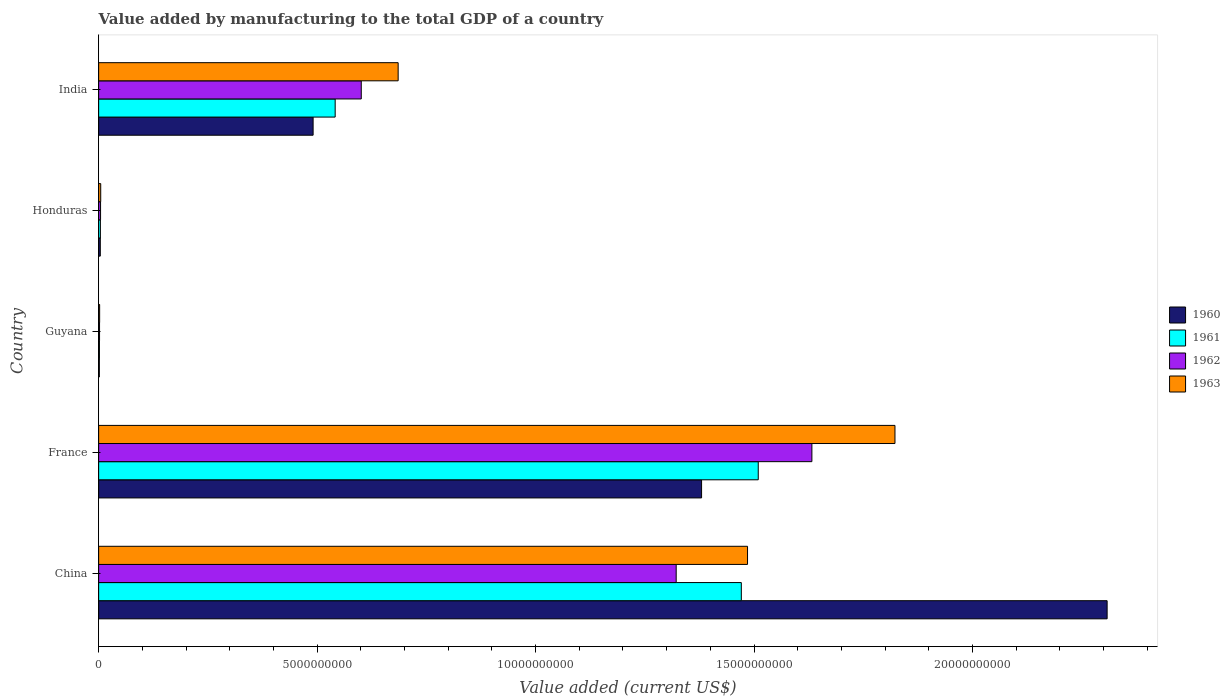How many groups of bars are there?
Your answer should be compact. 5. Are the number of bars per tick equal to the number of legend labels?
Your response must be concise. Yes. How many bars are there on the 4th tick from the top?
Your response must be concise. 4. What is the label of the 3rd group of bars from the top?
Provide a short and direct response. Guyana. What is the value added by manufacturing to the total GDP in 1963 in China?
Keep it short and to the point. 1.49e+1. Across all countries, what is the maximum value added by manufacturing to the total GDP in 1963?
Offer a very short reply. 1.82e+1. Across all countries, what is the minimum value added by manufacturing to the total GDP in 1961?
Provide a succinct answer. 1.84e+07. In which country was the value added by manufacturing to the total GDP in 1960 maximum?
Provide a succinct answer. China. In which country was the value added by manufacturing to the total GDP in 1963 minimum?
Your answer should be very brief. Guyana. What is the total value added by manufacturing to the total GDP in 1963 in the graph?
Your response must be concise. 4.00e+1. What is the difference between the value added by manufacturing to the total GDP in 1960 in China and that in Guyana?
Offer a terse response. 2.31e+1. What is the difference between the value added by manufacturing to the total GDP in 1960 in Honduras and the value added by manufacturing to the total GDP in 1961 in China?
Keep it short and to the point. -1.47e+1. What is the average value added by manufacturing to the total GDP in 1961 per country?
Give a very brief answer. 7.06e+09. What is the difference between the value added by manufacturing to the total GDP in 1962 and value added by manufacturing to the total GDP in 1960 in China?
Offer a very short reply. -9.86e+09. In how many countries, is the value added by manufacturing to the total GDP in 1962 greater than 13000000000 US$?
Ensure brevity in your answer.  2. What is the ratio of the value added by manufacturing to the total GDP in 1963 in France to that in Guyana?
Your answer should be compact. 786.97. What is the difference between the highest and the second highest value added by manufacturing to the total GDP in 1962?
Provide a short and direct response. 3.11e+09. What is the difference between the highest and the lowest value added by manufacturing to the total GDP in 1963?
Keep it short and to the point. 1.82e+1. In how many countries, is the value added by manufacturing to the total GDP in 1962 greater than the average value added by manufacturing to the total GDP in 1962 taken over all countries?
Your answer should be compact. 2. How many bars are there?
Offer a very short reply. 20. Are all the bars in the graph horizontal?
Provide a succinct answer. Yes. How many countries are there in the graph?
Your answer should be very brief. 5. Are the values on the major ticks of X-axis written in scientific E-notation?
Provide a short and direct response. No. Does the graph contain any zero values?
Offer a terse response. No. Does the graph contain grids?
Ensure brevity in your answer.  No. Where does the legend appear in the graph?
Keep it short and to the point. Center right. How many legend labels are there?
Ensure brevity in your answer.  4. How are the legend labels stacked?
Offer a very short reply. Vertical. What is the title of the graph?
Your answer should be very brief. Value added by manufacturing to the total GDP of a country. What is the label or title of the X-axis?
Your answer should be compact. Value added (current US$). What is the Value added (current US$) in 1960 in China?
Provide a short and direct response. 2.31e+1. What is the Value added (current US$) in 1961 in China?
Offer a terse response. 1.47e+1. What is the Value added (current US$) of 1962 in China?
Ensure brevity in your answer.  1.32e+1. What is the Value added (current US$) in 1963 in China?
Keep it short and to the point. 1.49e+1. What is the Value added (current US$) of 1960 in France?
Your answer should be very brief. 1.38e+1. What is the Value added (current US$) of 1961 in France?
Your answer should be compact. 1.51e+1. What is the Value added (current US$) of 1962 in France?
Keep it short and to the point. 1.63e+1. What is the Value added (current US$) of 1963 in France?
Offer a very short reply. 1.82e+1. What is the Value added (current US$) of 1960 in Guyana?
Provide a short and direct response. 1.59e+07. What is the Value added (current US$) in 1961 in Guyana?
Give a very brief answer. 1.84e+07. What is the Value added (current US$) of 1962 in Guyana?
Ensure brevity in your answer.  2.08e+07. What is the Value added (current US$) of 1963 in Guyana?
Provide a short and direct response. 2.32e+07. What is the Value added (current US$) in 1960 in Honduras?
Keep it short and to the point. 3.80e+07. What is the Value added (current US$) in 1961 in Honduras?
Keep it short and to the point. 4.00e+07. What is the Value added (current US$) in 1962 in Honduras?
Provide a short and direct response. 4.41e+07. What is the Value added (current US$) in 1963 in Honduras?
Offer a very short reply. 4.76e+07. What is the Value added (current US$) in 1960 in India?
Offer a very short reply. 4.91e+09. What is the Value added (current US$) of 1961 in India?
Make the answer very short. 5.41e+09. What is the Value added (current US$) in 1962 in India?
Your answer should be very brief. 6.01e+09. What is the Value added (current US$) of 1963 in India?
Provide a short and direct response. 6.85e+09. Across all countries, what is the maximum Value added (current US$) in 1960?
Your answer should be very brief. 2.31e+1. Across all countries, what is the maximum Value added (current US$) of 1961?
Provide a short and direct response. 1.51e+1. Across all countries, what is the maximum Value added (current US$) of 1962?
Offer a very short reply. 1.63e+1. Across all countries, what is the maximum Value added (current US$) of 1963?
Offer a very short reply. 1.82e+1. Across all countries, what is the minimum Value added (current US$) in 1960?
Give a very brief answer. 1.59e+07. Across all countries, what is the minimum Value added (current US$) of 1961?
Ensure brevity in your answer.  1.84e+07. Across all countries, what is the minimum Value added (current US$) in 1962?
Ensure brevity in your answer.  2.08e+07. Across all countries, what is the minimum Value added (current US$) of 1963?
Offer a very short reply. 2.32e+07. What is the total Value added (current US$) of 1960 in the graph?
Provide a succinct answer. 4.18e+1. What is the total Value added (current US$) in 1961 in the graph?
Give a very brief answer. 3.53e+1. What is the total Value added (current US$) of 1962 in the graph?
Provide a succinct answer. 3.56e+1. What is the total Value added (current US$) of 1963 in the graph?
Your answer should be compact. 4.00e+1. What is the difference between the Value added (current US$) of 1960 in China and that in France?
Offer a very short reply. 9.28e+09. What is the difference between the Value added (current US$) of 1961 in China and that in France?
Make the answer very short. -3.87e+08. What is the difference between the Value added (current US$) of 1962 in China and that in France?
Keep it short and to the point. -3.11e+09. What is the difference between the Value added (current US$) of 1963 in China and that in France?
Your answer should be compact. -3.37e+09. What is the difference between the Value added (current US$) in 1960 in China and that in Guyana?
Offer a very short reply. 2.31e+1. What is the difference between the Value added (current US$) in 1961 in China and that in Guyana?
Keep it short and to the point. 1.47e+1. What is the difference between the Value added (current US$) of 1962 in China and that in Guyana?
Offer a very short reply. 1.32e+1. What is the difference between the Value added (current US$) of 1963 in China and that in Guyana?
Make the answer very short. 1.48e+1. What is the difference between the Value added (current US$) in 1960 in China and that in Honduras?
Give a very brief answer. 2.30e+1. What is the difference between the Value added (current US$) of 1961 in China and that in Honduras?
Keep it short and to the point. 1.47e+1. What is the difference between the Value added (current US$) in 1962 in China and that in Honduras?
Your answer should be compact. 1.32e+1. What is the difference between the Value added (current US$) of 1963 in China and that in Honduras?
Provide a succinct answer. 1.48e+1. What is the difference between the Value added (current US$) of 1960 in China and that in India?
Your answer should be very brief. 1.82e+1. What is the difference between the Value added (current US$) of 1961 in China and that in India?
Your answer should be compact. 9.30e+09. What is the difference between the Value added (current US$) in 1962 in China and that in India?
Give a very brief answer. 7.21e+09. What is the difference between the Value added (current US$) of 1963 in China and that in India?
Offer a very short reply. 8.00e+09. What is the difference between the Value added (current US$) of 1960 in France and that in Guyana?
Give a very brief answer. 1.38e+1. What is the difference between the Value added (current US$) in 1961 in France and that in Guyana?
Your answer should be very brief. 1.51e+1. What is the difference between the Value added (current US$) of 1962 in France and that in Guyana?
Give a very brief answer. 1.63e+1. What is the difference between the Value added (current US$) in 1963 in France and that in Guyana?
Offer a very short reply. 1.82e+1. What is the difference between the Value added (current US$) in 1960 in France and that in Honduras?
Keep it short and to the point. 1.38e+1. What is the difference between the Value added (current US$) in 1961 in France and that in Honduras?
Give a very brief answer. 1.51e+1. What is the difference between the Value added (current US$) in 1962 in France and that in Honduras?
Give a very brief answer. 1.63e+1. What is the difference between the Value added (current US$) of 1963 in France and that in Honduras?
Give a very brief answer. 1.82e+1. What is the difference between the Value added (current US$) in 1960 in France and that in India?
Your response must be concise. 8.89e+09. What is the difference between the Value added (current US$) in 1961 in France and that in India?
Keep it short and to the point. 9.68e+09. What is the difference between the Value added (current US$) in 1962 in France and that in India?
Your response must be concise. 1.03e+1. What is the difference between the Value added (current US$) of 1963 in France and that in India?
Offer a terse response. 1.14e+1. What is the difference between the Value added (current US$) in 1960 in Guyana and that in Honduras?
Make the answer very short. -2.22e+07. What is the difference between the Value added (current US$) in 1961 in Guyana and that in Honduras?
Your response must be concise. -2.17e+07. What is the difference between the Value added (current US$) in 1962 in Guyana and that in Honduras?
Offer a terse response. -2.33e+07. What is the difference between the Value added (current US$) in 1963 in Guyana and that in Honduras?
Keep it short and to the point. -2.44e+07. What is the difference between the Value added (current US$) in 1960 in Guyana and that in India?
Provide a succinct answer. -4.89e+09. What is the difference between the Value added (current US$) in 1961 in Guyana and that in India?
Give a very brief answer. -5.40e+09. What is the difference between the Value added (current US$) in 1962 in Guyana and that in India?
Your answer should be very brief. -5.99e+09. What is the difference between the Value added (current US$) in 1963 in Guyana and that in India?
Provide a short and direct response. -6.83e+09. What is the difference between the Value added (current US$) of 1960 in Honduras and that in India?
Make the answer very short. -4.87e+09. What is the difference between the Value added (current US$) in 1961 in Honduras and that in India?
Provide a succinct answer. -5.37e+09. What is the difference between the Value added (current US$) in 1962 in Honduras and that in India?
Keep it short and to the point. -5.97e+09. What is the difference between the Value added (current US$) of 1963 in Honduras and that in India?
Ensure brevity in your answer.  -6.81e+09. What is the difference between the Value added (current US$) of 1960 in China and the Value added (current US$) of 1961 in France?
Ensure brevity in your answer.  7.98e+09. What is the difference between the Value added (current US$) of 1960 in China and the Value added (current US$) of 1962 in France?
Your answer should be very brief. 6.76e+09. What is the difference between the Value added (current US$) in 1960 in China and the Value added (current US$) in 1963 in France?
Offer a very short reply. 4.86e+09. What is the difference between the Value added (current US$) in 1961 in China and the Value added (current US$) in 1962 in France?
Keep it short and to the point. -1.61e+09. What is the difference between the Value added (current US$) in 1961 in China and the Value added (current US$) in 1963 in France?
Offer a very short reply. -3.52e+09. What is the difference between the Value added (current US$) in 1962 in China and the Value added (current US$) in 1963 in France?
Provide a succinct answer. -5.01e+09. What is the difference between the Value added (current US$) of 1960 in China and the Value added (current US$) of 1961 in Guyana?
Your answer should be compact. 2.31e+1. What is the difference between the Value added (current US$) in 1960 in China and the Value added (current US$) in 1962 in Guyana?
Provide a short and direct response. 2.31e+1. What is the difference between the Value added (current US$) of 1960 in China and the Value added (current US$) of 1963 in Guyana?
Offer a terse response. 2.31e+1. What is the difference between the Value added (current US$) of 1961 in China and the Value added (current US$) of 1962 in Guyana?
Your answer should be very brief. 1.47e+1. What is the difference between the Value added (current US$) of 1961 in China and the Value added (current US$) of 1963 in Guyana?
Offer a very short reply. 1.47e+1. What is the difference between the Value added (current US$) in 1962 in China and the Value added (current US$) in 1963 in Guyana?
Give a very brief answer. 1.32e+1. What is the difference between the Value added (current US$) in 1960 in China and the Value added (current US$) in 1961 in Honduras?
Your answer should be very brief. 2.30e+1. What is the difference between the Value added (current US$) of 1960 in China and the Value added (current US$) of 1962 in Honduras?
Give a very brief answer. 2.30e+1. What is the difference between the Value added (current US$) in 1960 in China and the Value added (current US$) in 1963 in Honduras?
Offer a terse response. 2.30e+1. What is the difference between the Value added (current US$) in 1961 in China and the Value added (current US$) in 1962 in Honduras?
Offer a terse response. 1.47e+1. What is the difference between the Value added (current US$) in 1961 in China and the Value added (current US$) in 1963 in Honduras?
Make the answer very short. 1.47e+1. What is the difference between the Value added (current US$) of 1962 in China and the Value added (current US$) of 1963 in Honduras?
Ensure brevity in your answer.  1.32e+1. What is the difference between the Value added (current US$) of 1960 in China and the Value added (current US$) of 1961 in India?
Provide a succinct answer. 1.77e+1. What is the difference between the Value added (current US$) of 1960 in China and the Value added (current US$) of 1962 in India?
Your response must be concise. 1.71e+1. What is the difference between the Value added (current US$) in 1960 in China and the Value added (current US$) in 1963 in India?
Your response must be concise. 1.62e+1. What is the difference between the Value added (current US$) of 1961 in China and the Value added (current US$) of 1962 in India?
Your response must be concise. 8.70e+09. What is the difference between the Value added (current US$) of 1961 in China and the Value added (current US$) of 1963 in India?
Give a very brief answer. 7.85e+09. What is the difference between the Value added (current US$) in 1962 in China and the Value added (current US$) in 1963 in India?
Ensure brevity in your answer.  6.36e+09. What is the difference between the Value added (current US$) of 1960 in France and the Value added (current US$) of 1961 in Guyana?
Make the answer very short. 1.38e+1. What is the difference between the Value added (current US$) of 1960 in France and the Value added (current US$) of 1962 in Guyana?
Your answer should be very brief. 1.38e+1. What is the difference between the Value added (current US$) of 1960 in France and the Value added (current US$) of 1963 in Guyana?
Make the answer very short. 1.38e+1. What is the difference between the Value added (current US$) of 1961 in France and the Value added (current US$) of 1962 in Guyana?
Make the answer very short. 1.51e+1. What is the difference between the Value added (current US$) of 1961 in France and the Value added (current US$) of 1963 in Guyana?
Offer a terse response. 1.51e+1. What is the difference between the Value added (current US$) of 1962 in France and the Value added (current US$) of 1963 in Guyana?
Give a very brief answer. 1.63e+1. What is the difference between the Value added (current US$) of 1960 in France and the Value added (current US$) of 1961 in Honduras?
Offer a very short reply. 1.38e+1. What is the difference between the Value added (current US$) in 1960 in France and the Value added (current US$) in 1962 in Honduras?
Offer a very short reply. 1.38e+1. What is the difference between the Value added (current US$) of 1960 in France and the Value added (current US$) of 1963 in Honduras?
Ensure brevity in your answer.  1.38e+1. What is the difference between the Value added (current US$) of 1961 in France and the Value added (current US$) of 1962 in Honduras?
Keep it short and to the point. 1.51e+1. What is the difference between the Value added (current US$) of 1961 in France and the Value added (current US$) of 1963 in Honduras?
Provide a short and direct response. 1.50e+1. What is the difference between the Value added (current US$) in 1962 in France and the Value added (current US$) in 1963 in Honduras?
Your answer should be very brief. 1.63e+1. What is the difference between the Value added (current US$) in 1960 in France and the Value added (current US$) in 1961 in India?
Your answer should be compact. 8.39e+09. What is the difference between the Value added (current US$) in 1960 in France and the Value added (current US$) in 1962 in India?
Your response must be concise. 7.79e+09. What is the difference between the Value added (current US$) in 1960 in France and the Value added (current US$) in 1963 in India?
Ensure brevity in your answer.  6.94e+09. What is the difference between the Value added (current US$) of 1961 in France and the Value added (current US$) of 1962 in India?
Your response must be concise. 9.09e+09. What is the difference between the Value added (current US$) of 1961 in France and the Value added (current US$) of 1963 in India?
Provide a short and direct response. 8.24e+09. What is the difference between the Value added (current US$) in 1962 in France and the Value added (current US$) in 1963 in India?
Your answer should be very brief. 9.47e+09. What is the difference between the Value added (current US$) in 1960 in Guyana and the Value added (current US$) in 1961 in Honduras?
Ensure brevity in your answer.  -2.42e+07. What is the difference between the Value added (current US$) in 1960 in Guyana and the Value added (current US$) in 1962 in Honduras?
Offer a terse response. -2.82e+07. What is the difference between the Value added (current US$) of 1960 in Guyana and the Value added (current US$) of 1963 in Honduras?
Provide a succinct answer. -3.17e+07. What is the difference between the Value added (current US$) of 1961 in Guyana and the Value added (current US$) of 1962 in Honduras?
Offer a very short reply. -2.57e+07. What is the difference between the Value added (current US$) of 1961 in Guyana and the Value added (current US$) of 1963 in Honduras?
Your response must be concise. -2.92e+07. What is the difference between the Value added (current US$) in 1962 in Guyana and the Value added (current US$) in 1963 in Honduras?
Make the answer very short. -2.68e+07. What is the difference between the Value added (current US$) in 1960 in Guyana and the Value added (current US$) in 1961 in India?
Make the answer very short. -5.40e+09. What is the difference between the Value added (current US$) of 1960 in Guyana and the Value added (current US$) of 1962 in India?
Provide a succinct answer. -5.99e+09. What is the difference between the Value added (current US$) of 1960 in Guyana and the Value added (current US$) of 1963 in India?
Your response must be concise. -6.84e+09. What is the difference between the Value added (current US$) in 1961 in Guyana and the Value added (current US$) in 1962 in India?
Offer a very short reply. -5.99e+09. What is the difference between the Value added (current US$) of 1961 in Guyana and the Value added (current US$) of 1963 in India?
Your response must be concise. -6.84e+09. What is the difference between the Value added (current US$) of 1962 in Guyana and the Value added (current US$) of 1963 in India?
Keep it short and to the point. -6.83e+09. What is the difference between the Value added (current US$) of 1960 in Honduras and the Value added (current US$) of 1961 in India?
Offer a very short reply. -5.38e+09. What is the difference between the Value added (current US$) in 1960 in Honduras and the Value added (current US$) in 1962 in India?
Provide a succinct answer. -5.97e+09. What is the difference between the Value added (current US$) in 1960 in Honduras and the Value added (current US$) in 1963 in India?
Provide a short and direct response. -6.82e+09. What is the difference between the Value added (current US$) of 1961 in Honduras and the Value added (current US$) of 1962 in India?
Your answer should be compact. -5.97e+09. What is the difference between the Value added (current US$) in 1961 in Honduras and the Value added (current US$) in 1963 in India?
Your answer should be very brief. -6.81e+09. What is the difference between the Value added (current US$) in 1962 in Honduras and the Value added (current US$) in 1963 in India?
Offer a very short reply. -6.81e+09. What is the average Value added (current US$) of 1960 per country?
Offer a very short reply. 8.37e+09. What is the average Value added (current US$) in 1961 per country?
Provide a short and direct response. 7.06e+09. What is the average Value added (current US$) in 1962 per country?
Your answer should be compact. 7.12e+09. What is the average Value added (current US$) in 1963 per country?
Your answer should be compact. 8.00e+09. What is the difference between the Value added (current US$) in 1960 and Value added (current US$) in 1961 in China?
Your answer should be very brief. 8.37e+09. What is the difference between the Value added (current US$) in 1960 and Value added (current US$) in 1962 in China?
Make the answer very short. 9.86e+09. What is the difference between the Value added (current US$) in 1960 and Value added (current US$) in 1963 in China?
Offer a very short reply. 8.23e+09. What is the difference between the Value added (current US$) in 1961 and Value added (current US$) in 1962 in China?
Keep it short and to the point. 1.49e+09. What is the difference between the Value added (current US$) of 1961 and Value added (current US$) of 1963 in China?
Provide a succinct answer. -1.42e+08. What is the difference between the Value added (current US$) of 1962 and Value added (current US$) of 1963 in China?
Make the answer very short. -1.63e+09. What is the difference between the Value added (current US$) in 1960 and Value added (current US$) in 1961 in France?
Offer a terse response. -1.30e+09. What is the difference between the Value added (current US$) of 1960 and Value added (current US$) of 1962 in France?
Provide a short and direct response. -2.52e+09. What is the difference between the Value added (current US$) in 1960 and Value added (current US$) in 1963 in France?
Ensure brevity in your answer.  -4.43e+09. What is the difference between the Value added (current US$) in 1961 and Value added (current US$) in 1962 in France?
Provide a short and direct response. -1.23e+09. What is the difference between the Value added (current US$) of 1961 and Value added (current US$) of 1963 in France?
Give a very brief answer. -3.13e+09. What is the difference between the Value added (current US$) of 1962 and Value added (current US$) of 1963 in France?
Offer a very short reply. -1.90e+09. What is the difference between the Value added (current US$) in 1960 and Value added (current US$) in 1961 in Guyana?
Offer a terse response. -2.51e+06. What is the difference between the Value added (current US$) in 1960 and Value added (current US$) in 1962 in Guyana?
Give a very brief answer. -4.90e+06. What is the difference between the Value added (current US$) of 1960 and Value added (current US$) of 1963 in Guyana?
Your answer should be compact. -7.29e+06. What is the difference between the Value added (current US$) of 1961 and Value added (current US$) of 1962 in Guyana?
Provide a short and direct response. -2.39e+06. What is the difference between the Value added (current US$) in 1961 and Value added (current US$) in 1963 in Guyana?
Give a very brief answer. -4.78e+06. What is the difference between the Value added (current US$) of 1962 and Value added (current US$) of 1963 in Guyana?
Offer a very short reply. -2.39e+06. What is the difference between the Value added (current US$) in 1960 and Value added (current US$) in 1961 in Honduras?
Give a very brief answer. -2.00e+06. What is the difference between the Value added (current US$) in 1960 and Value added (current US$) in 1962 in Honduras?
Provide a short and direct response. -6.05e+06. What is the difference between the Value added (current US$) of 1960 and Value added (current US$) of 1963 in Honduras?
Provide a short and direct response. -9.50e+06. What is the difference between the Value added (current US$) of 1961 and Value added (current US$) of 1962 in Honduras?
Give a very brief answer. -4.05e+06. What is the difference between the Value added (current US$) in 1961 and Value added (current US$) in 1963 in Honduras?
Provide a succinct answer. -7.50e+06. What is the difference between the Value added (current US$) in 1962 and Value added (current US$) in 1963 in Honduras?
Offer a very short reply. -3.45e+06. What is the difference between the Value added (current US$) in 1960 and Value added (current US$) in 1961 in India?
Give a very brief answer. -5.05e+08. What is the difference between the Value added (current US$) in 1960 and Value added (current US$) in 1962 in India?
Your answer should be very brief. -1.10e+09. What is the difference between the Value added (current US$) of 1960 and Value added (current US$) of 1963 in India?
Give a very brief answer. -1.95e+09. What is the difference between the Value added (current US$) in 1961 and Value added (current US$) in 1962 in India?
Provide a succinct answer. -5.97e+08. What is the difference between the Value added (current US$) in 1961 and Value added (current US$) in 1963 in India?
Provide a short and direct response. -1.44e+09. What is the difference between the Value added (current US$) in 1962 and Value added (current US$) in 1963 in India?
Ensure brevity in your answer.  -8.44e+08. What is the ratio of the Value added (current US$) in 1960 in China to that in France?
Offer a terse response. 1.67. What is the ratio of the Value added (current US$) of 1961 in China to that in France?
Make the answer very short. 0.97. What is the ratio of the Value added (current US$) of 1962 in China to that in France?
Provide a short and direct response. 0.81. What is the ratio of the Value added (current US$) of 1963 in China to that in France?
Provide a short and direct response. 0.81. What is the ratio of the Value added (current US$) in 1960 in China to that in Guyana?
Your answer should be compact. 1454.66. What is the ratio of the Value added (current US$) in 1961 in China to that in Guyana?
Give a very brief answer. 800.48. What is the ratio of the Value added (current US$) in 1962 in China to that in Guyana?
Keep it short and to the point. 636.5. What is the ratio of the Value added (current US$) in 1963 in China to that in Guyana?
Provide a short and direct response. 641.28. What is the ratio of the Value added (current US$) of 1960 in China to that in Honduras?
Offer a terse response. 606.59. What is the ratio of the Value added (current US$) in 1961 in China to that in Honduras?
Your answer should be very brief. 367.26. What is the ratio of the Value added (current US$) of 1962 in China to that in Honduras?
Make the answer very short. 299.73. What is the ratio of the Value added (current US$) of 1963 in China to that in Honduras?
Ensure brevity in your answer.  312.32. What is the ratio of the Value added (current US$) in 1960 in China to that in India?
Keep it short and to the point. 4.7. What is the ratio of the Value added (current US$) of 1961 in China to that in India?
Provide a short and direct response. 2.72. What is the ratio of the Value added (current US$) of 1962 in China to that in India?
Offer a very short reply. 2.2. What is the ratio of the Value added (current US$) in 1963 in China to that in India?
Your response must be concise. 2.17. What is the ratio of the Value added (current US$) of 1960 in France to that in Guyana?
Keep it short and to the point. 869.7. What is the ratio of the Value added (current US$) in 1961 in France to that in Guyana?
Offer a very short reply. 821.55. What is the ratio of the Value added (current US$) in 1962 in France to that in Guyana?
Offer a terse response. 786.05. What is the ratio of the Value added (current US$) of 1963 in France to that in Guyana?
Provide a succinct answer. 786.97. What is the ratio of the Value added (current US$) in 1960 in France to that in Honduras?
Provide a short and direct response. 362.66. What is the ratio of the Value added (current US$) of 1961 in France to that in Honduras?
Your answer should be very brief. 376.93. What is the ratio of the Value added (current US$) of 1962 in France to that in Honduras?
Your response must be concise. 370.15. What is the ratio of the Value added (current US$) in 1963 in France to that in Honduras?
Your answer should be compact. 383.28. What is the ratio of the Value added (current US$) in 1960 in France to that in India?
Provide a succinct answer. 2.81. What is the ratio of the Value added (current US$) of 1961 in France to that in India?
Your answer should be very brief. 2.79. What is the ratio of the Value added (current US$) of 1962 in France to that in India?
Offer a very short reply. 2.72. What is the ratio of the Value added (current US$) in 1963 in France to that in India?
Provide a short and direct response. 2.66. What is the ratio of the Value added (current US$) of 1960 in Guyana to that in Honduras?
Offer a very short reply. 0.42. What is the ratio of the Value added (current US$) in 1961 in Guyana to that in Honduras?
Make the answer very short. 0.46. What is the ratio of the Value added (current US$) of 1962 in Guyana to that in Honduras?
Provide a short and direct response. 0.47. What is the ratio of the Value added (current US$) of 1963 in Guyana to that in Honduras?
Offer a terse response. 0.49. What is the ratio of the Value added (current US$) in 1960 in Guyana to that in India?
Your answer should be very brief. 0. What is the ratio of the Value added (current US$) of 1961 in Guyana to that in India?
Offer a very short reply. 0. What is the ratio of the Value added (current US$) of 1962 in Guyana to that in India?
Your answer should be compact. 0. What is the ratio of the Value added (current US$) in 1963 in Guyana to that in India?
Offer a terse response. 0. What is the ratio of the Value added (current US$) in 1960 in Honduras to that in India?
Your answer should be very brief. 0.01. What is the ratio of the Value added (current US$) in 1961 in Honduras to that in India?
Your answer should be compact. 0.01. What is the ratio of the Value added (current US$) in 1962 in Honduras to that in India?
Offer a terse response. 0.01. What is the ratio of the Value added (current US$) in 1963 in Honduras to that in India?
Your answer should be very brief. 0.01. What is the difference between the highest and the second highest Value added (current US$) in 1960?
Your response must be concise. 9.28e+09. What is the difference between the highest and the second highest Value added (current US$) in 1961?
Your answer should be very brief. 3.87e+08. What is the difference between the highest and the second highest Value added (current US$) of 1962?
Provide a short and direct response. 3.11e+09. What is the difference between the highest and the second highest Value added (current US$) of 1963?
Offer a terse response. 3.37e+09. What is the difference between the highest and the lowest Value added (current US$) in 1960?
Your answer should be compact. 2.31e+1. What is the difference between the highest and the lowest Value added (current US$) of 1961?
Offer a terse response. 1.51e+1. What is the difference between the highest and the lowest Value added (current US$) in 1962?
Give a very brief answer. 1.63e+1. What is the difference between the highest and the lowest Value added (current US$) of 1963?
Offer a very short reply. 1.82e+1. 